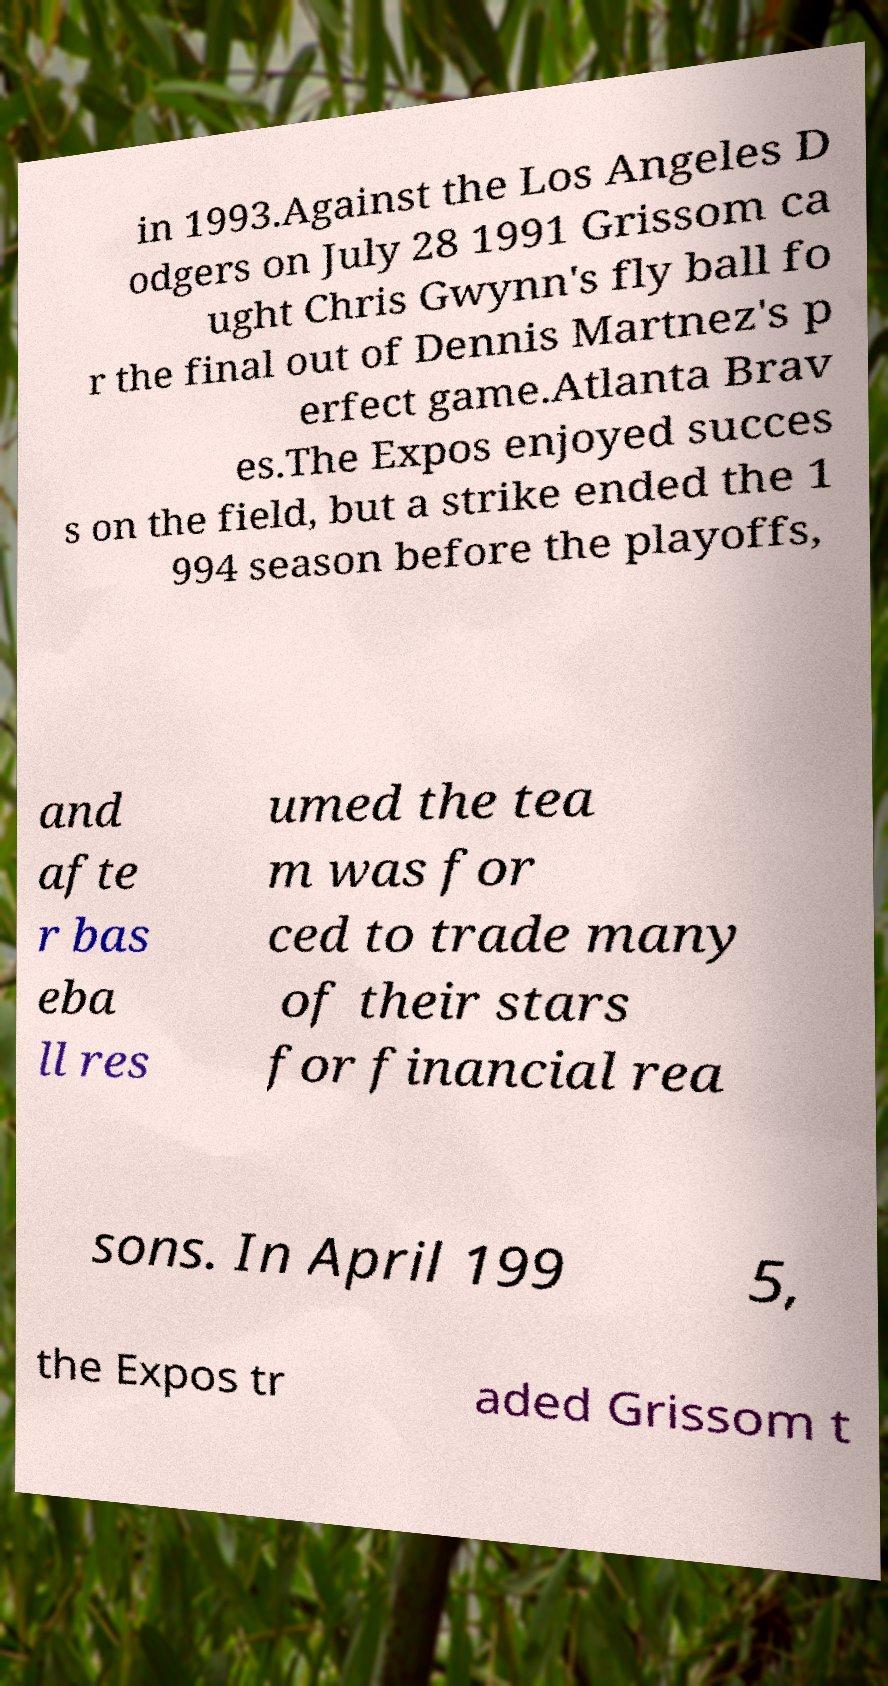There's text embedded in this image that I need extracted. Can you transcribe it verbatim? in 1993.Against the Los Angeles D odgers on July 28 1991 Grissom ca ught Chris Gwynn's fly ball fo r the final out of Dennis Martnez's p erfect game.Atlanta Brav es.The Expos enjoyed succes s on the field, but a strike ended the 1 994 season before the playoffs, and afte r bas eba ll res umed the tea m was for ced to trade many of their stars for financial rea sons. In April 199 5, the Expos tr aded Grissom t 